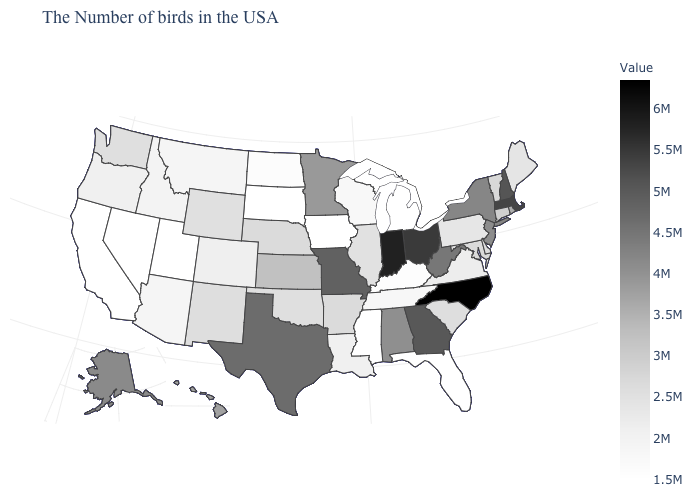Among the states that border Mississippi , which have the lowest value?
Answer briefly. Tennessee. Among the states that border Colorado , which have the highest value?
Give a very brief answer. Kansas. Which states have the highest value in the USA?
Quick response, please. North Carolina. Does New Mexico have a lower value than Indiana?
Answer briefly. Yes. Does Indiana have the highest value in the MidWest?
Quick response, please. Yes. 